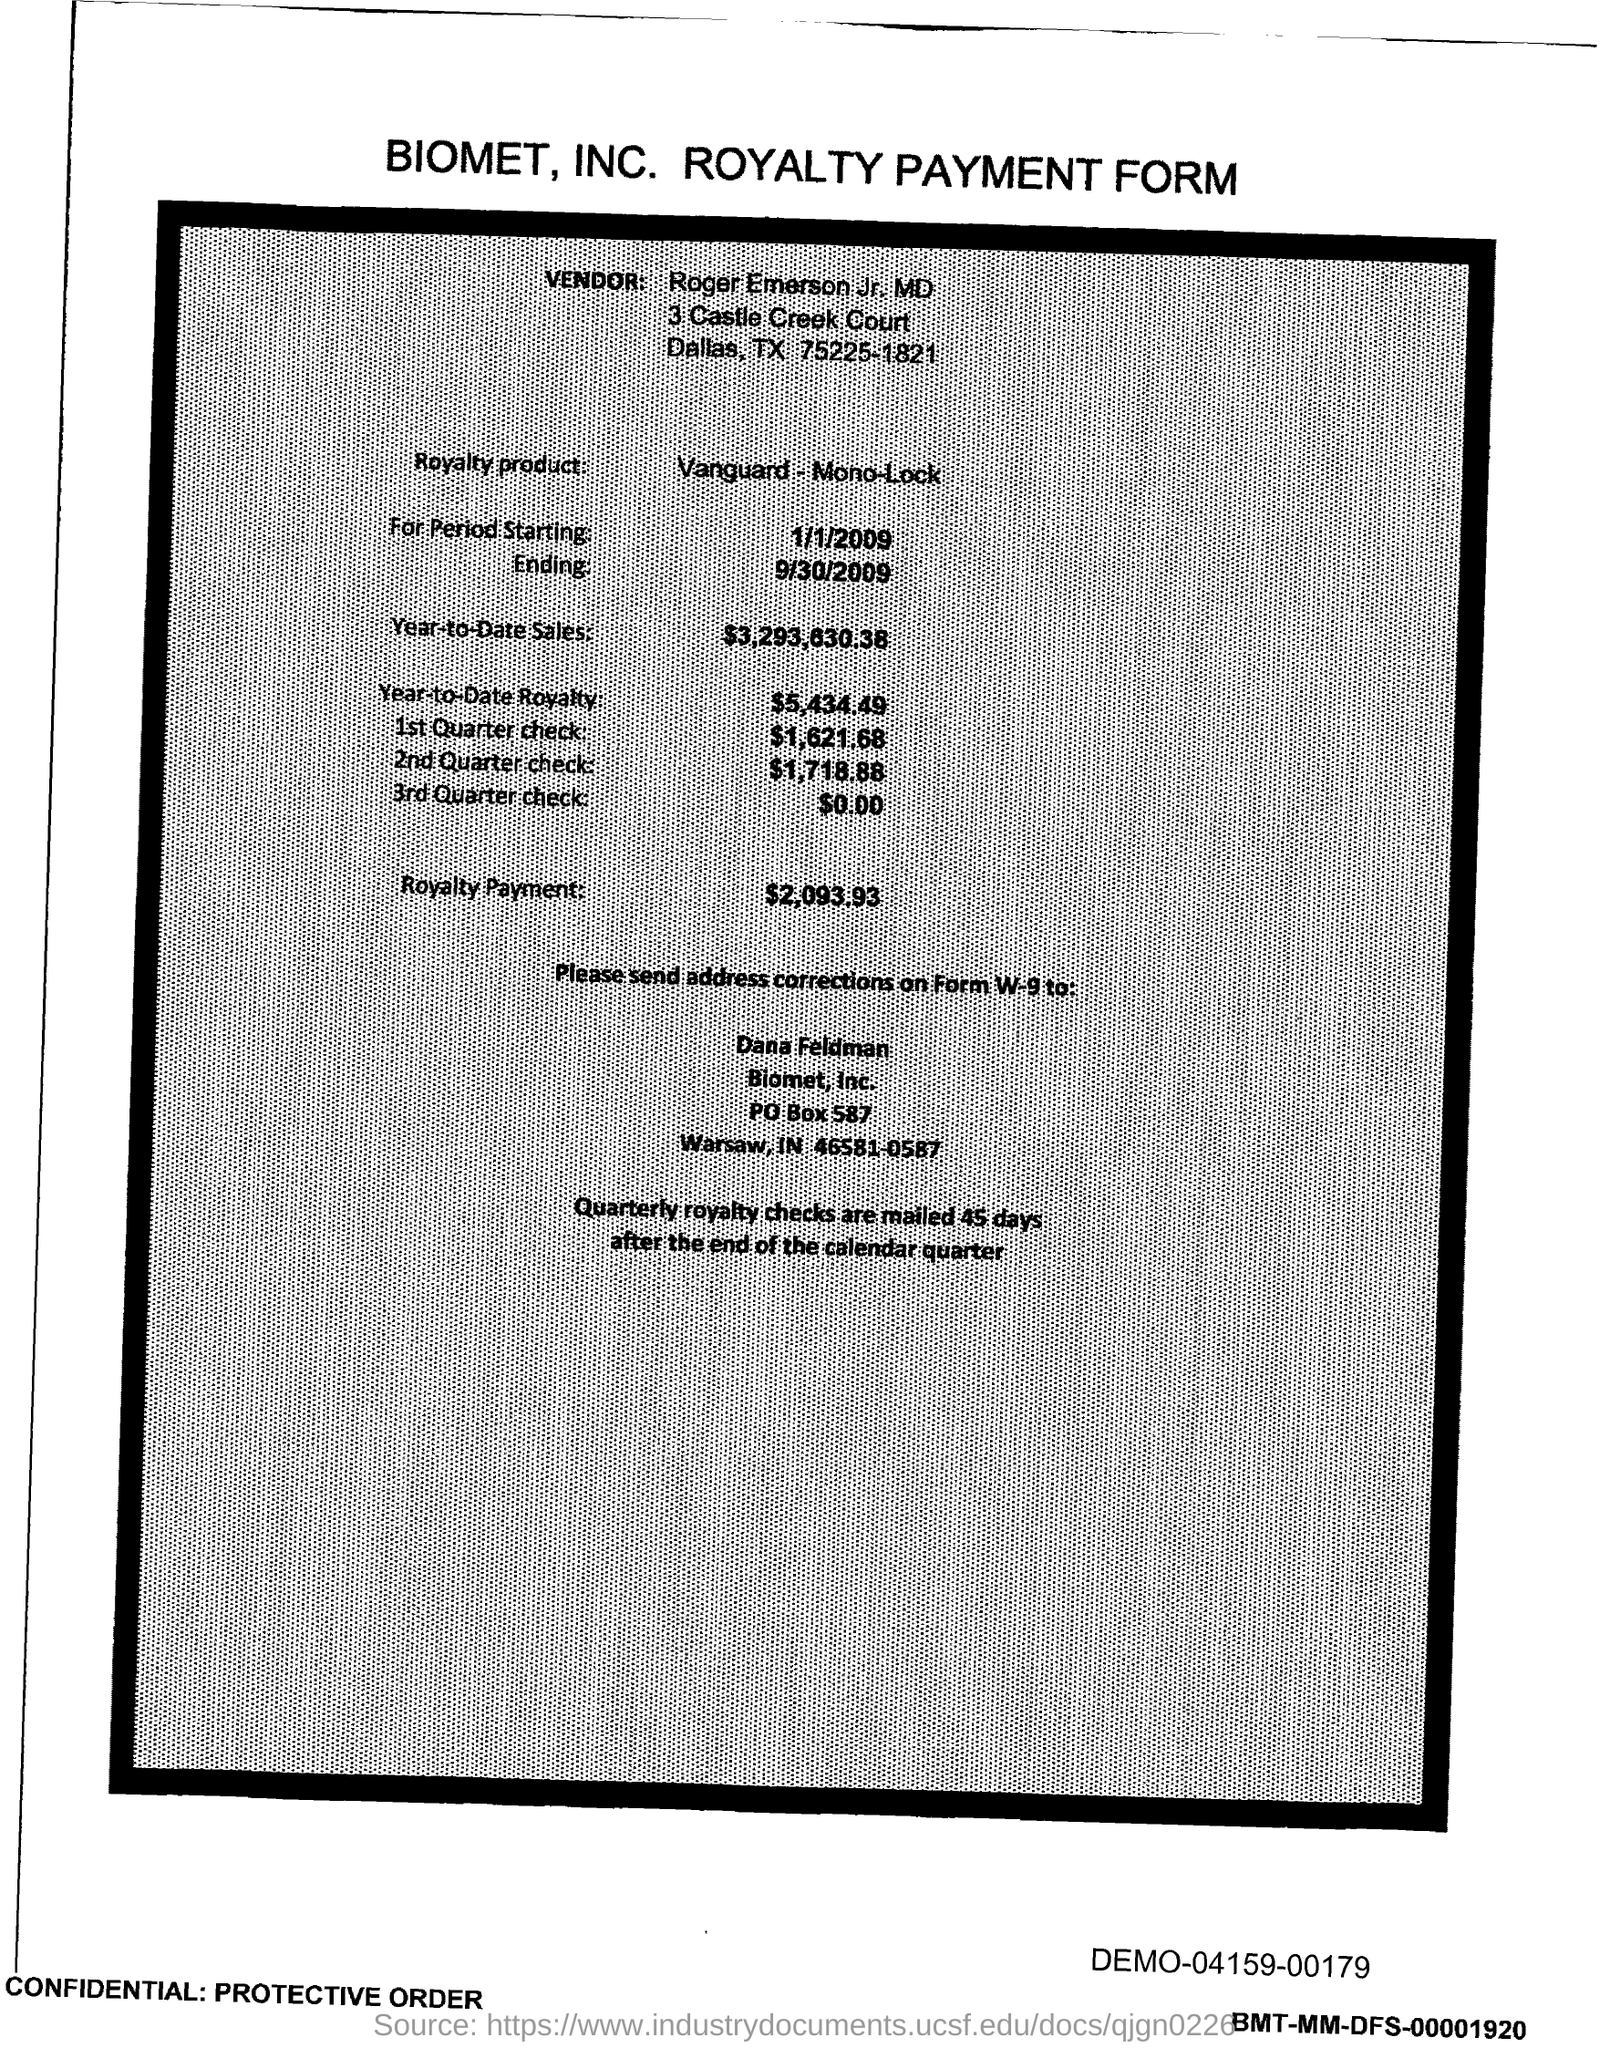What is the PO Box Number mentioned in the document?
Provide a short and direct response. 587. 